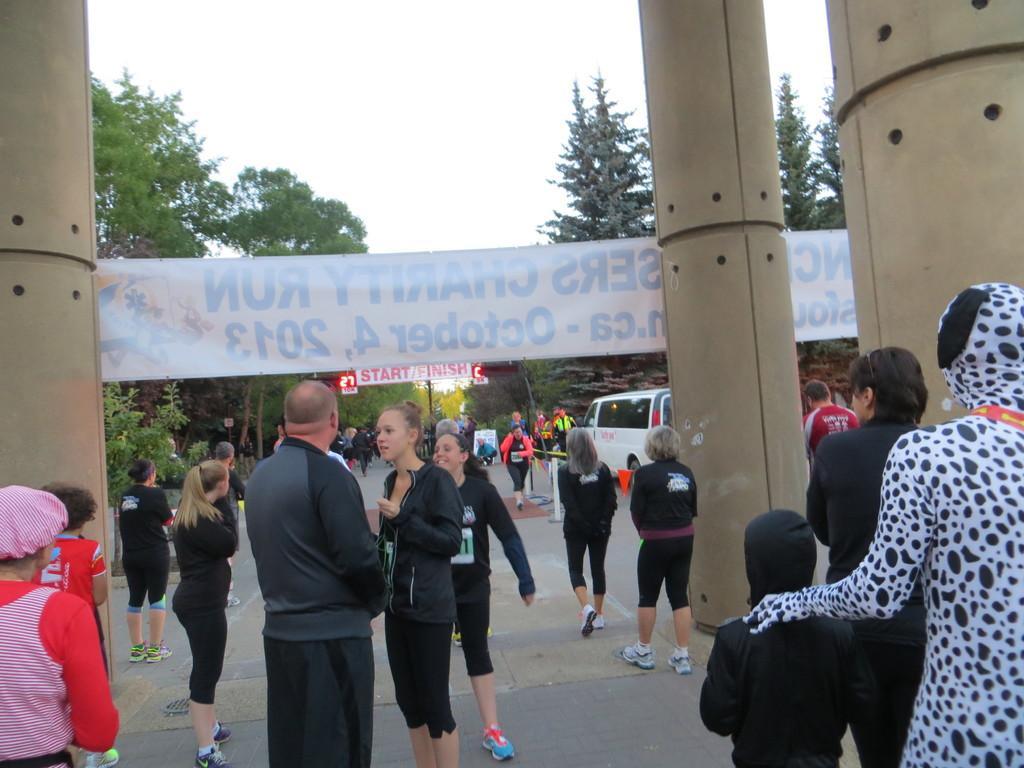How would you summarize this image in a sentence or two? In this picture there is a woman wearing a black jacket and track standing and talking to the man. Behind there are three brown pillars with white banner hanging on it. In the background there are some girls walking on the road. 